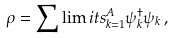<formula> <loc_0><loc_0><loc_500><loc_500>\rho = \sum \lim i t s _ { k = 1 } ^ { A } \psi ^ { \dagger } _ { k } \psi _ { k } \, ,</formula> 